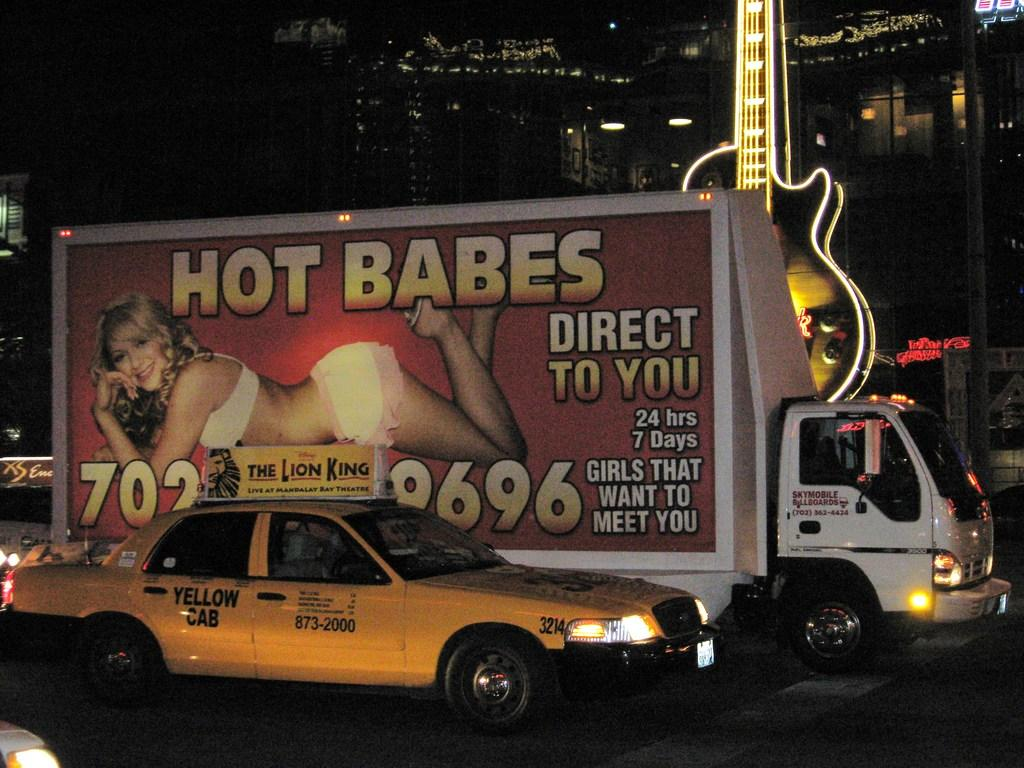<image>
Relay a brief, clear account of the picture shown. Sky Mobile Billboards advertising van is in traffic. 